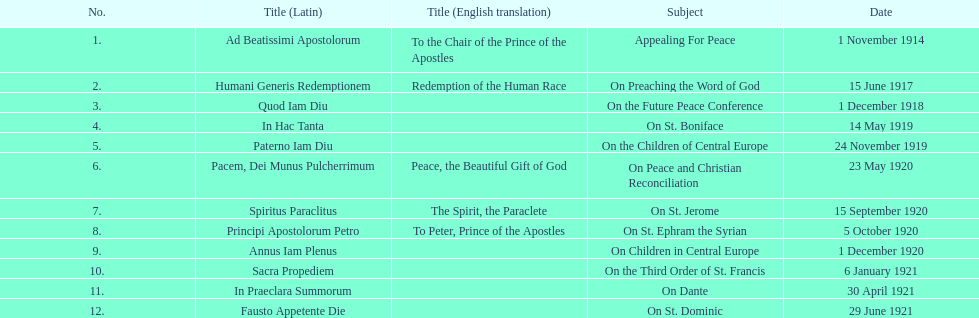What was the quantity of encyclopedias containing topics particularly focused on children? 2. 